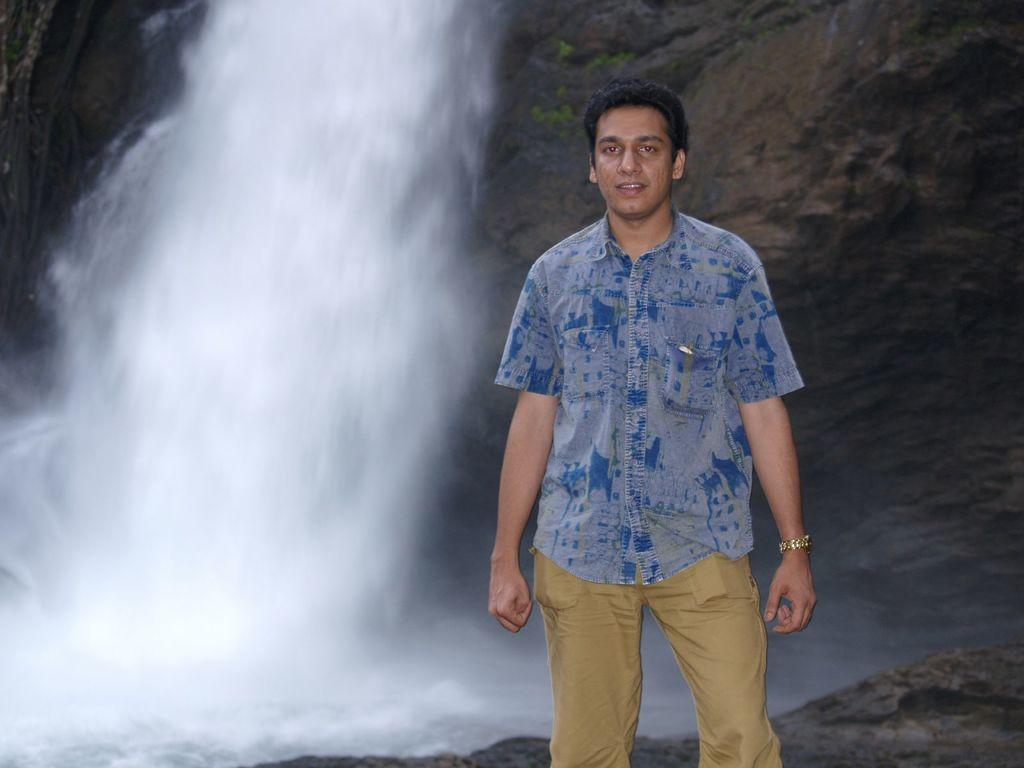What is the main subject of the image? There is a man standing in the center of the image. What is the man's facial expression? The man is smiling. What can be seen in the background of the image? There is a hill and water visible in the background of the image. What type of drop can be seen falling from the sky in the image? There is no drop falling from the sky in the image. What is the man doing to stop the car in the image? There is no car or need to stop in the image; it features a man standing and smiling. 